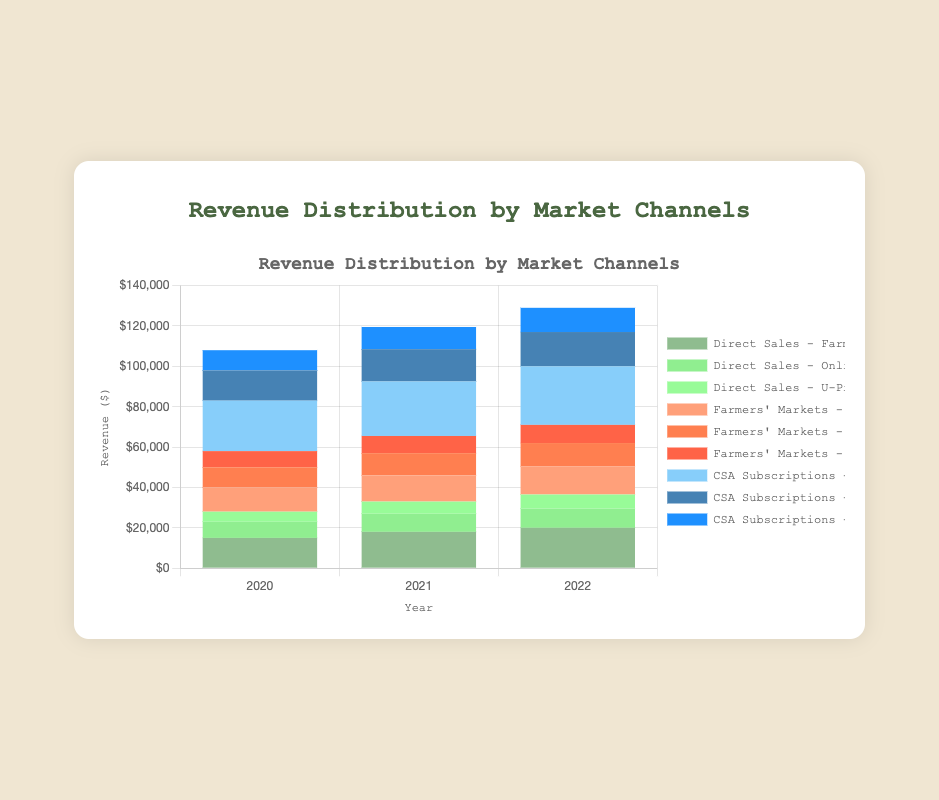What is the total revenue from Farmers' Markets in 2020? To find the total revenue from Farmers' Markets in 2020, sum the revenues from "City Market," "Town Market," and "Village Market." The values given are 12000, 10000, and 8000 respectively. So, 12000 + 10000 + 8000 = 30000.
Answer: 30000 Which year had the highest revenue from CSA Subscriptions' Full-Season program? Compare the revenue from CSA Subscriptions' Full-Season program across the years. The values are 25000 in 2020, 27000 in 2021, and 29000 in 2022. The highest value is in 2022.
Answer: 2022 What was the total revenue from Direct Sales in 2021? To find the total revenue from Direct Sales in 2021, sum the revenues from "Farm Stand," "Online Store," and "U-Pick." The values given are 18000, 9000, and 6000 respectively. So, 18000 + 9000 + 6000 = 33000.
Answer: 33000 How does the revenue from the Town Market compare between 2020 and 2022? Check the revenue from the Town Market in both 2020 and 2022. The values are 10000 in 2020 and 11500 in 2022. Therefore, the revenue increased from 2020 to 2022.
Answer: increased Which CSA Subscription program had the least revenue in 2020? Compare the revenues from "Full-Season," "Half-Season," and "Winter Program" in 2020. The values are 25000, 15000, and 10000 respectively. The least revenue was from the "Winter Program" at 10000.
Answer: Winter Program What is the average annual revenue from the Online Store from 2020 to 2022? To find the average annual revenue, sum the revenues from 2020, 2021, and 2022, then divide by 3. The values are 8000, 9000, and 9500. So, (8000 + 9000 + 9500) / 3 = 26500 / 3 = 8833.33.
Answer: 8833.33 Which year had the highest total revenue from all market channels combined? To find which year had the highest total revenue, sum all revenues for each year and compare them. For 2020: 15000 + 8000 + 5000 + 12000 + 10000 + 8000 + 25000 + 15000 + 10000 = 108000. For 2021: 18000 + 9000 + 6000 + 13000 + 11000 + 8500 + 27000 + 16000 + 11000 = 119500. For 2022: 20000 + 9500 + 7000 + 14000 + 11500 + 9000 + 29000 + 17000 + 12000 = 129000. 2022 had the highest total revenue.
Answer: 2022 What was the difference in revenue between the Farm Stand and the Village Market in 2020? Determine the revenue for the Farm Stand and Village Market in 2020. Farm Stand is 15000, and Village Market is 8000. The difference is 15000 - 8000 = 7000.
Answer: 7000 Which revenue stream saw the largest overall increase from 2020 to 2022? Compare the revenues for each stream in 2020 and 2022. Calculate the increase for each: Farm Stand (20000 - 15000 = 5000), Online Store (9500 - 8000 = 1500), U-Pick (7000 - 5000 = 2000), City Market (14000 - 12000 = 2000), Town Market (11500 - 10000 = 1500), Village Market (9000 - 8000 = 1000), Full-Season (29000 - 25000 = 4000), Half-Season (17000 - 15000 = 2000), Winter Program (12000 - 10000 = 2000). The Farm Stand saw the largest increase of 5000.
Answer: Farm Stand 